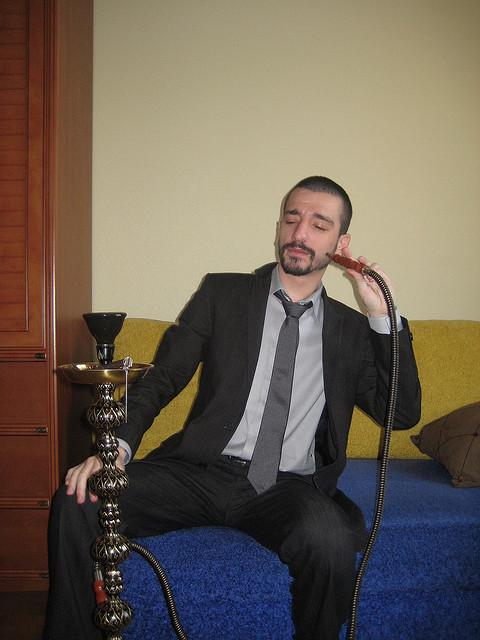What comes through the pipe held here?

Choices:
A) smoke
B) cookies
C) milk
D) oil smoke 